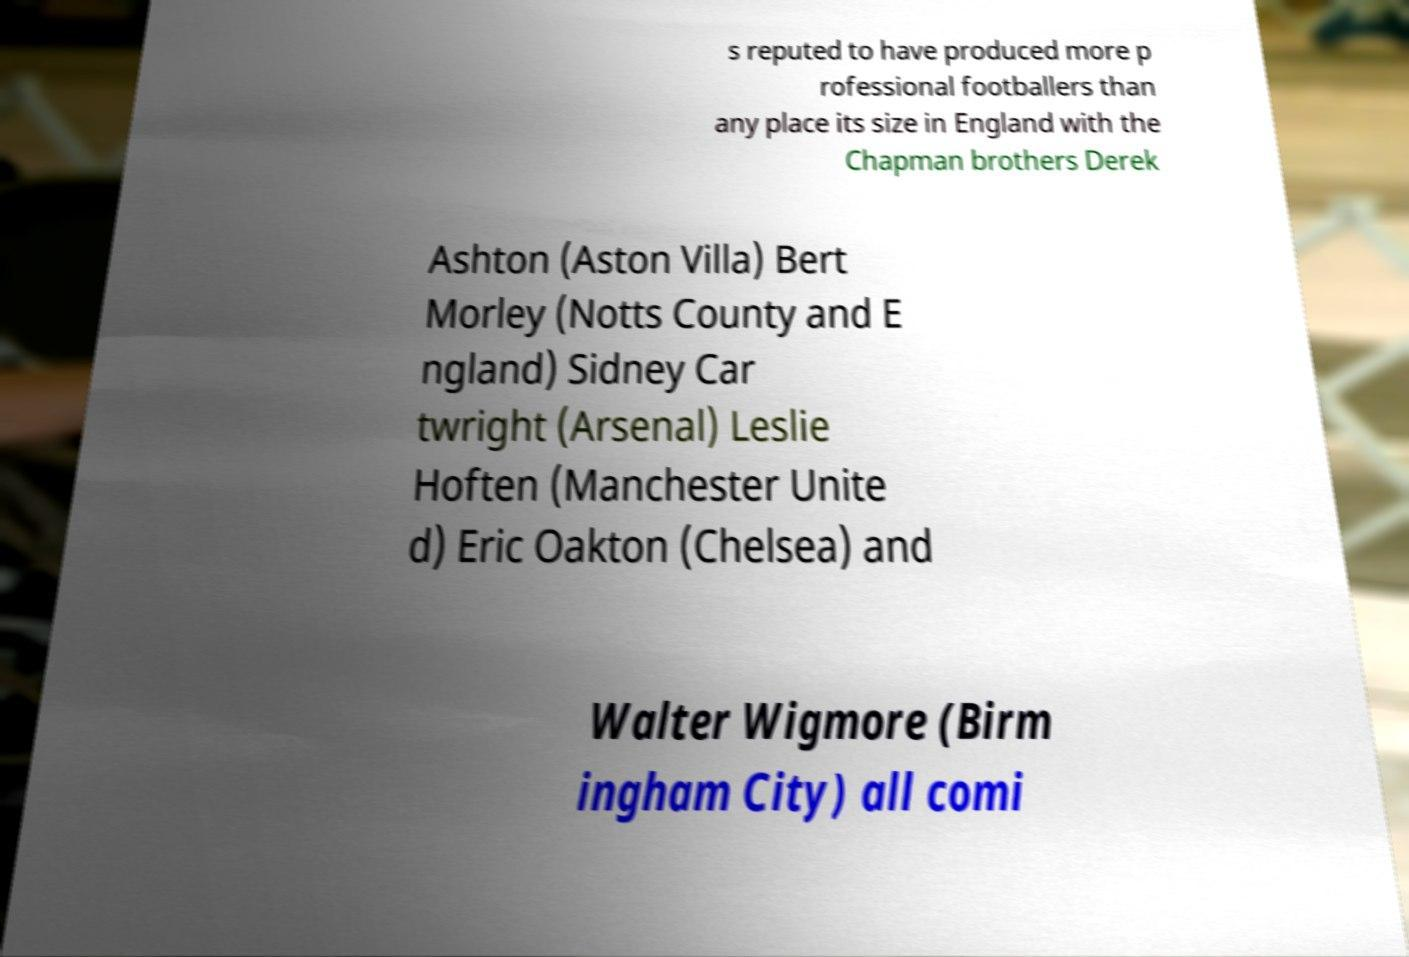Can you read and provide the text displayed in the image?This photo seems to have some interesting text. Can you extract and type it out for me? s reputed to have produced more p rofessional footballers than any place its size in England with the Chapman brothers Derek Ashton (Aston Villa) Bert Morley (Notts County and E ngland) Sidney Car twright (Arsenal) Leslie Hoften (Manchester Unite d) Eric Oakton (Chelsea) and Walter Wigmore (Birm ingham City) all comi 